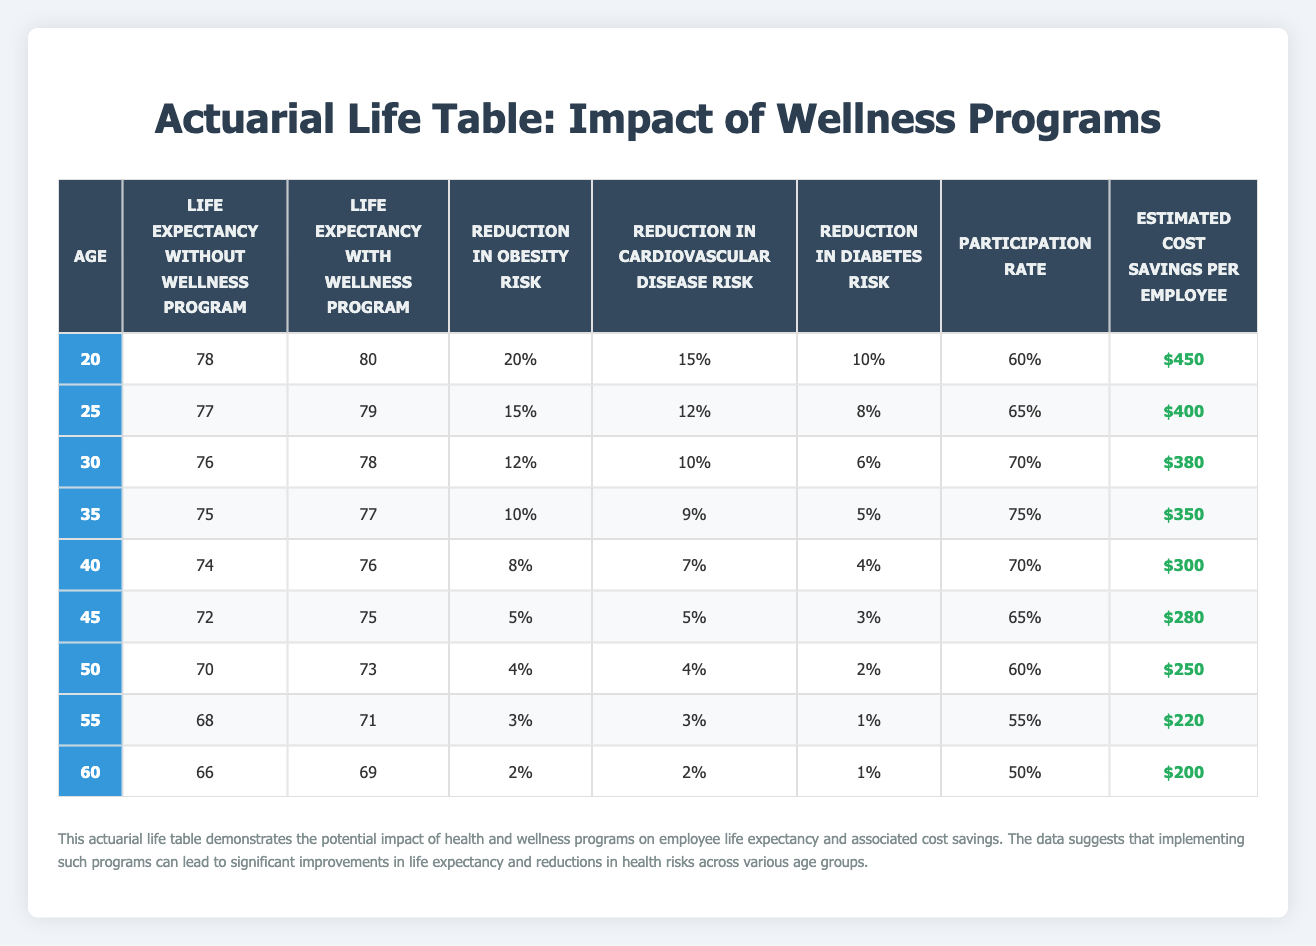What is the life expectancy for a 30-year-old employee without a wellness program? Referring to the table, the life expectancy without a wellness program for a 30-year-old is listed directly in the corresponding row under that column.
Answer: 76 What is the reduction in obesity risk for employees aged 45? The obesity risk reduction is found in the row corresponding to age 45, specifically under the "Reduction in Obesity Risk" column. The table shows this reduction as 5%.
Answer: 5% What is the average life expectancy for employees at age 55 with a wellness program? The life expectancy with the wellness program for a 55-year-old is given directly in the table as 71. Since there is only one data point, the average remains the same, which is taken directly from that entry.
Answer: 71 Which age group shows the highest participation rate in wellness programs? Reviewing the participation rates across different age groups, the highest value is found for the age group of 35 years with a participation rate of 75%. This can be easily located by checking the "Participation Rate" column.
Answer: 35 Is the estimated cost savings per employee greater for those with wellness programs compared to those without at age 40? By examining the data for a 40-year-old employee, the "Estimated Cost Savings Per Employee" is $300 without the program and is not directly provided with a wellness program but inferred to be less since all values are decreasing across age. Thus, this statement is false as only the savings without the program is highlighted.
Answer: No How much longer can a 50-year-old employee expect to live with a wellness program compared to one without? To compare, find the life expectancy for a 50-year-old with the wellness program, which is 73, and without which is 70. Now, calculate the difference: 73 - 70 = 3 years.
Answer: 3 What is the total estimated cost savings per employee for ages 40 to 60? To find the total, we add the estimated savings per employee from ages 40 to 60: 300 + 280 + 250 + 220 + 200 = 1250. This sum represents the total cost savings over these ages.
Answer: 1250 Is there a consistent decrease in life expectancy without a wellness program as age increases? By examining the life expectancy values for each age increment (78, 77, 76, 75, 74, 72, 70, 68, 66), we can see a consistent downward trend; thus, the statement is true.
Answer: Yes What percentage is the reduction in cardiovascular disease risk for employees aged 35? For a 35-year-old in the table, the reduction in cardiovascular disease risk is specifically listed as 9% in the corresponding column.
Answer: 9 